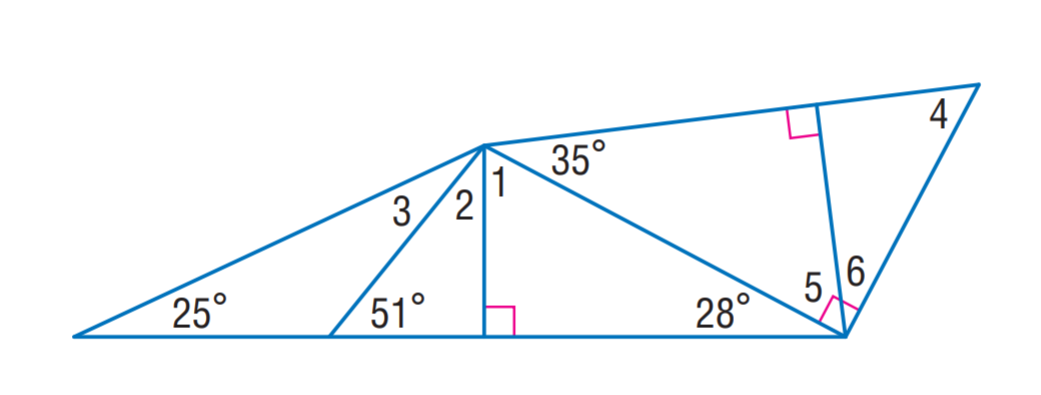Question: Find m \angle 1.
Choices:
A. 39
B. 55
C. 62
D. 83
Answer with the letter. Answer: C Question: Find m \angle 3.
Choices:
A. 26
B. 39
C. 55
D. 62
Answer with the letter. Answer: A Question: Find m \angle 4.
Choices:
A. 26
B. 39
C. 55
D. 62
Answer with the letter. Answer: C Question: Find m \angle 5.
Choices:
A. 35
B. 39
C. 55
D. 62
Answer with the letter. Answer: C Question: Find m \angle 2.
Choices:
A. 26
B. 39
C. 55
D. 62
Answer with the letter. Answer: B 